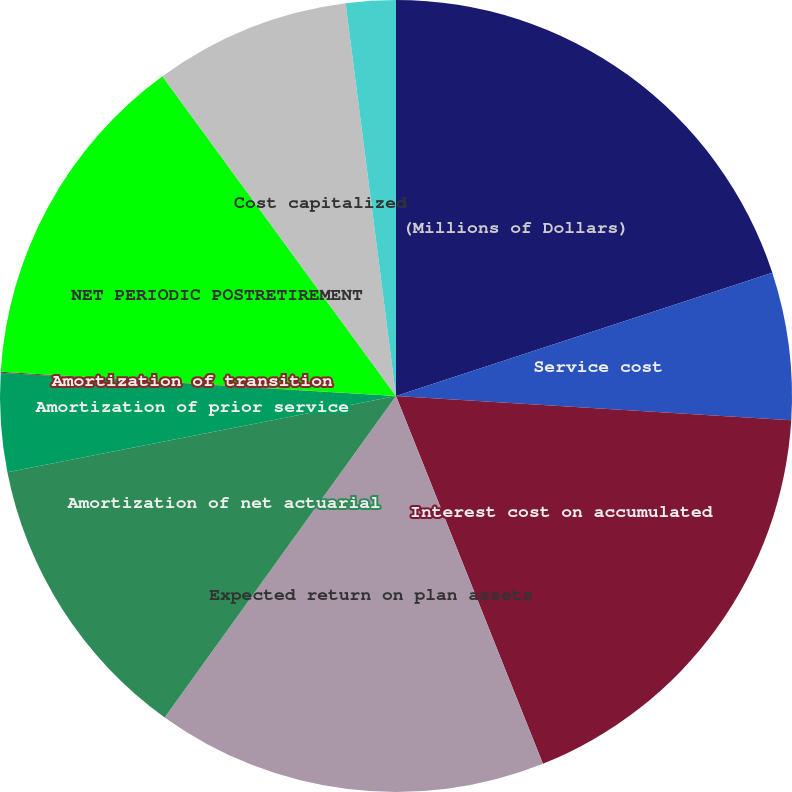Convert chart. <chart><loc_0><loc_0><loc_500><loc_500><pie_chart><fcel>(Millions of Dollars)<fcel>Service cost<fcel>Interest cost on accumulated<fcel>Expected return on plan assets<fcel>Amortization of net actuarial<fcel>Amortization of prior service<fcel>Amortization of transition<fcel>NET PERIODIC POSTRETIREMENT<fcel>Cost capitalized<fcel>Cost charged/(deferred)<nl><fcel>19.96%<fcel>6.02%<fcel>17.97%<fcel>15.98%<fcel>11.99%<fcel>4.02%<fcel>0.04%<fcel>13.98%<fcel>8.01%<fcel>2.03%<nl></chart> 